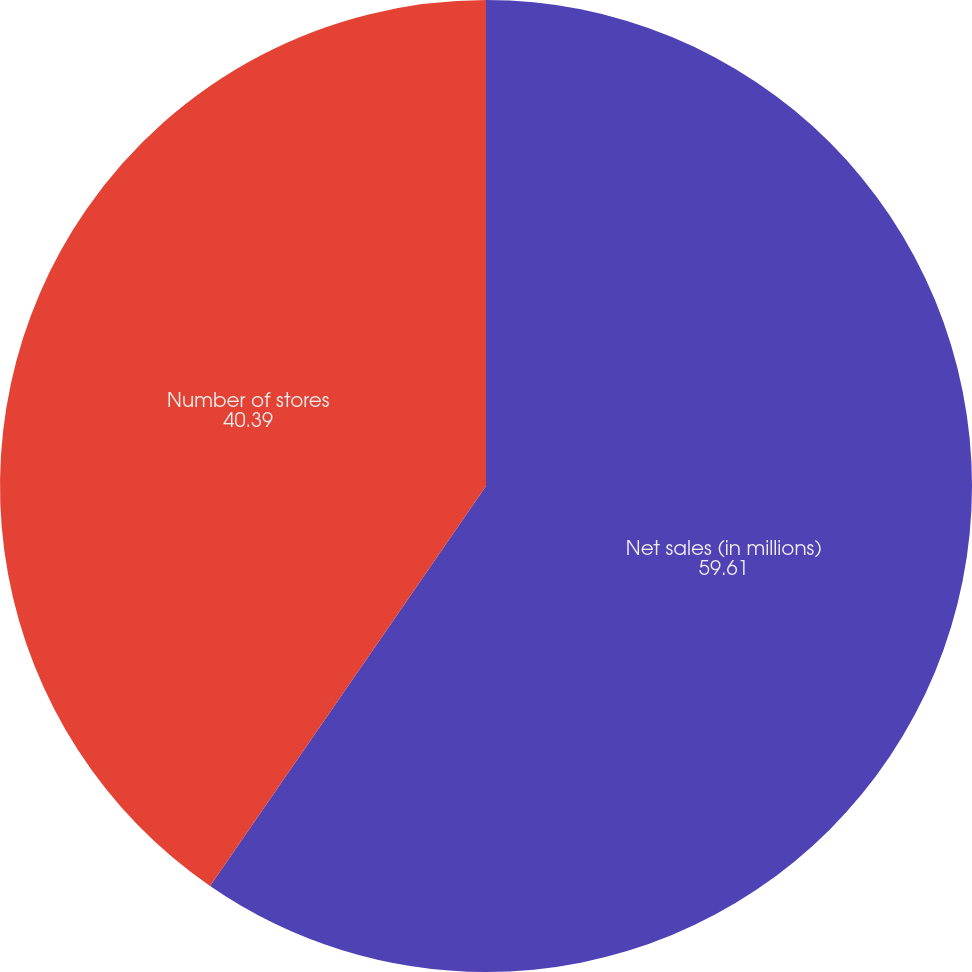Convert chart to OTSL. <chart><loc_0><loc_0><loc_500><loc_500><pie_chart><fcel>Net sales (in millions)<fcel>Number of stores<nl><fcel>59.61%<fcel>40.39%<nl></chart> 